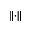<formula> <loc_0><loc_0><loc_500><loc_500>\left \| \cdot \right \|</formula> 